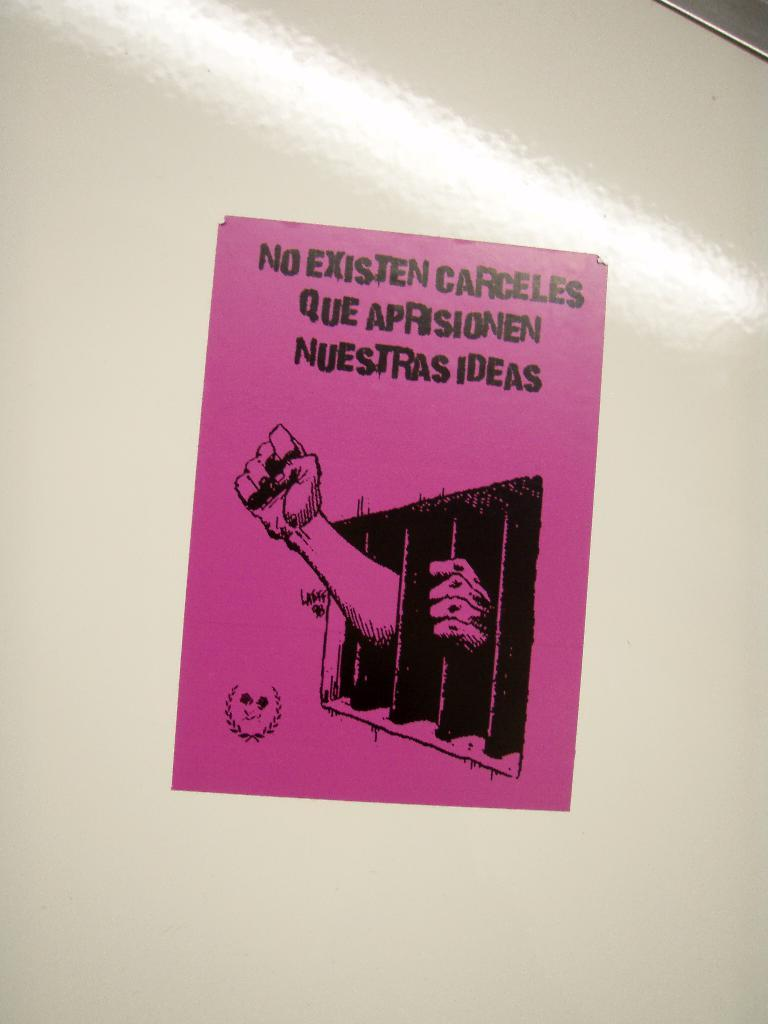Provide a one-sentence caption for the provided image. A flyer in Spanish fights for not imprisoning the people's ideas. 